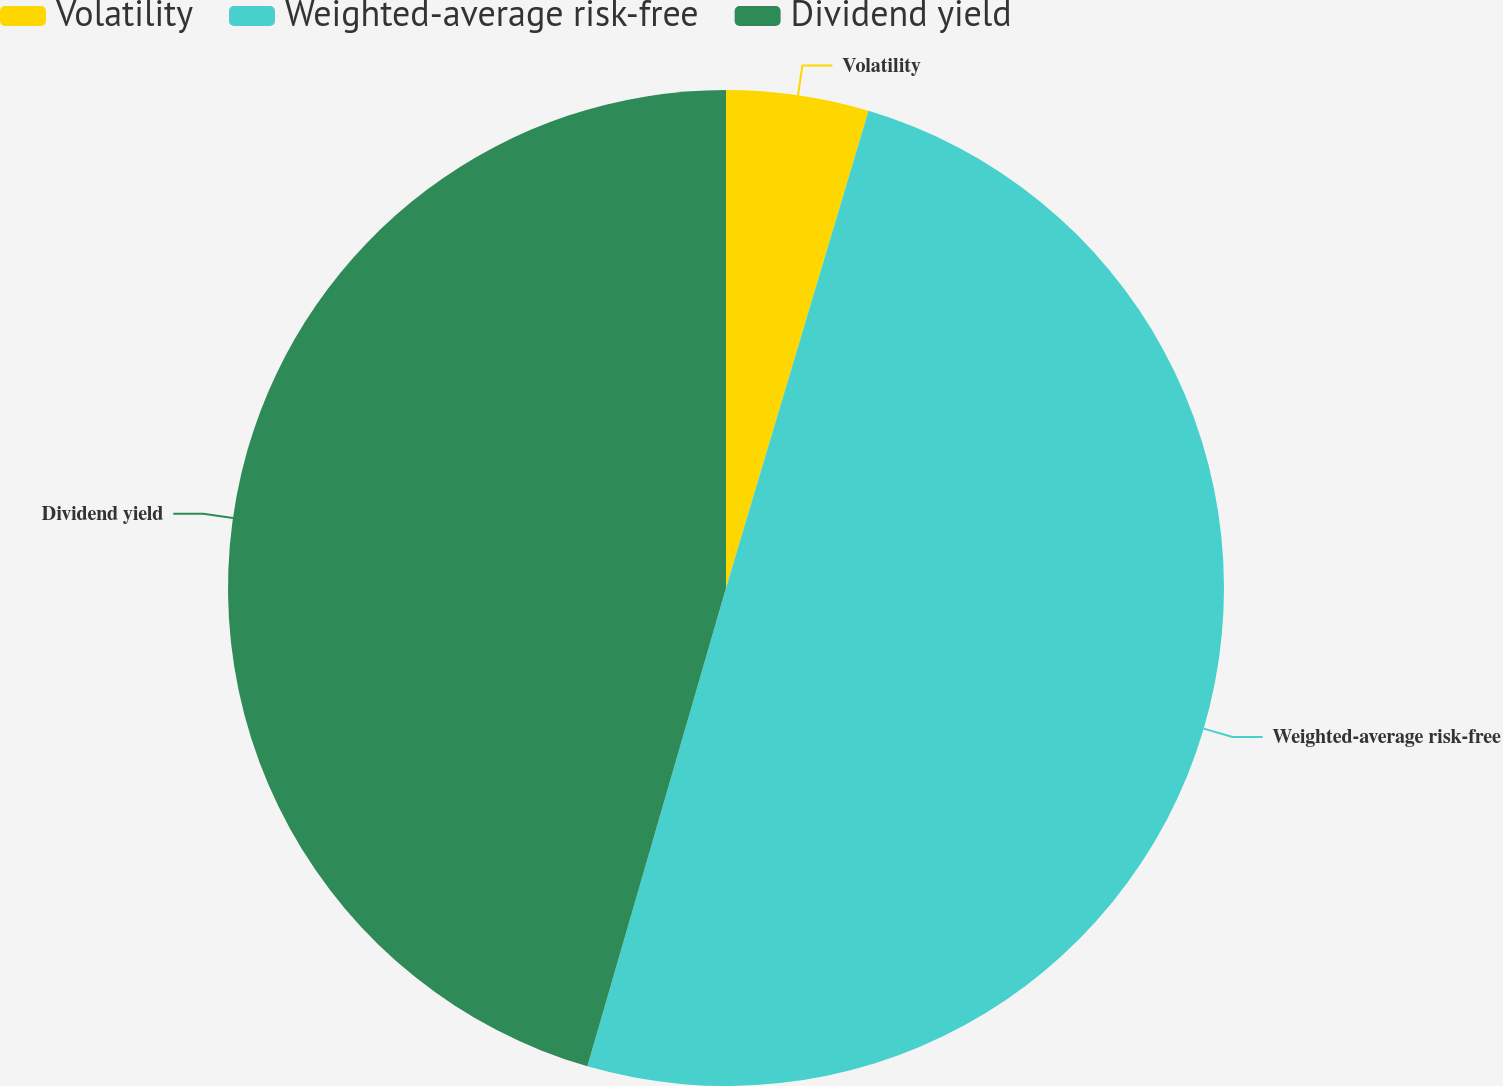Convert chart. <chart><loc_0><loc_0><loc_500><loc_500><pie_chart><fcel>Volatility<fcel>Weighted-average risk-free<fcel>Dividend yield<nl><fcel>4.62%<fcel>49.87%<fcel>45.51%<nl></chart> 